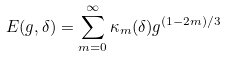<formula> <loc_0><loc_0><loc_500><loc_500>E ( g , \delta ) = \sum _ { m = 0 } ^ { \infty } { \kappa } _ { m } ( \delta ) g ^ { ( 1 - 2 m ) / 3 }</formula> 